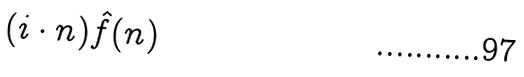<formula> <loc_0><loc_0><loc_500><loc_500>( i \cdot n ) \hat { f } ( n )</formula> 